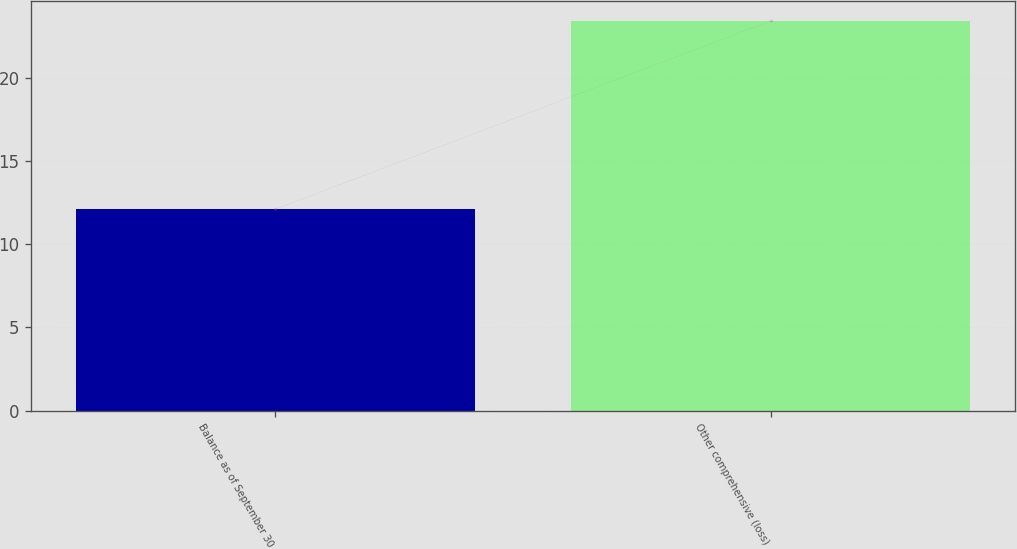Convert chart to OTSL. <chart><loc_0><loc_0><loc_500><loc_500><bar_chart><fcel>Balance as of September 30<fcel>Other comprehensive (loss)<nl><fcel>12.1<fcel>23.4<nl></chart> 